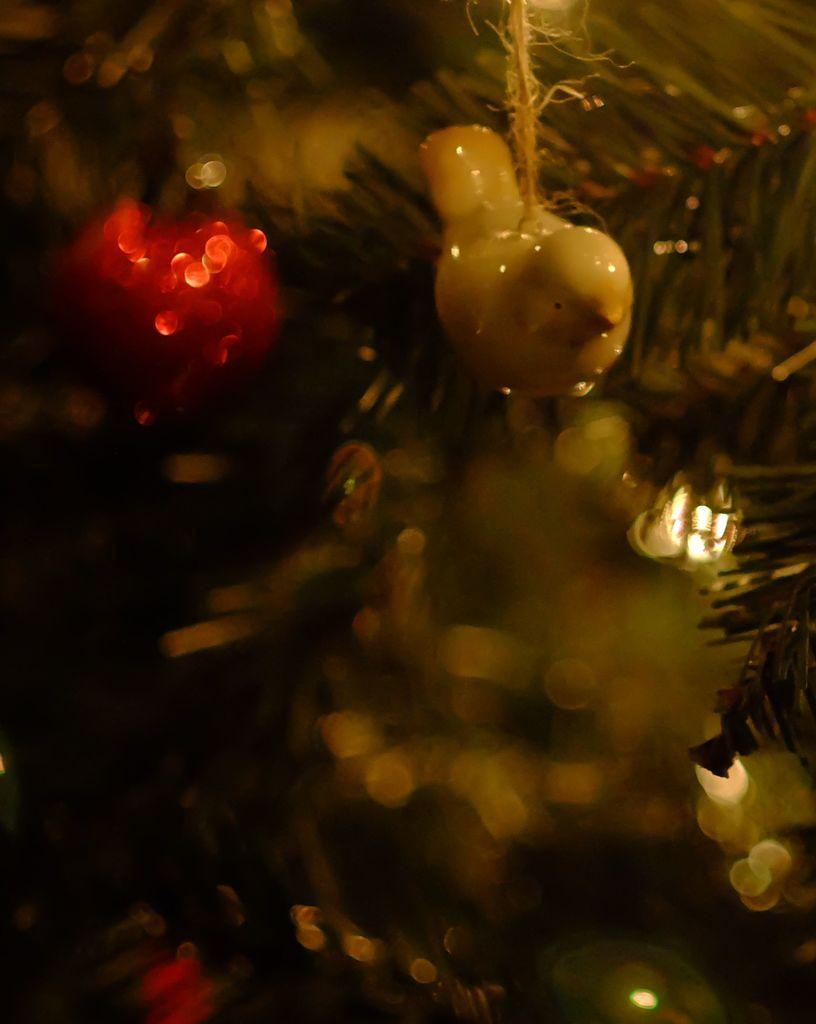Could you give a brief overview of what you see in this image? In this image there is a toy, in the background it is blurred. 